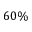Convert formula to latex. <formula><loc_0><loc_0><loc_500><loc_500>6 0 \%</formula> 